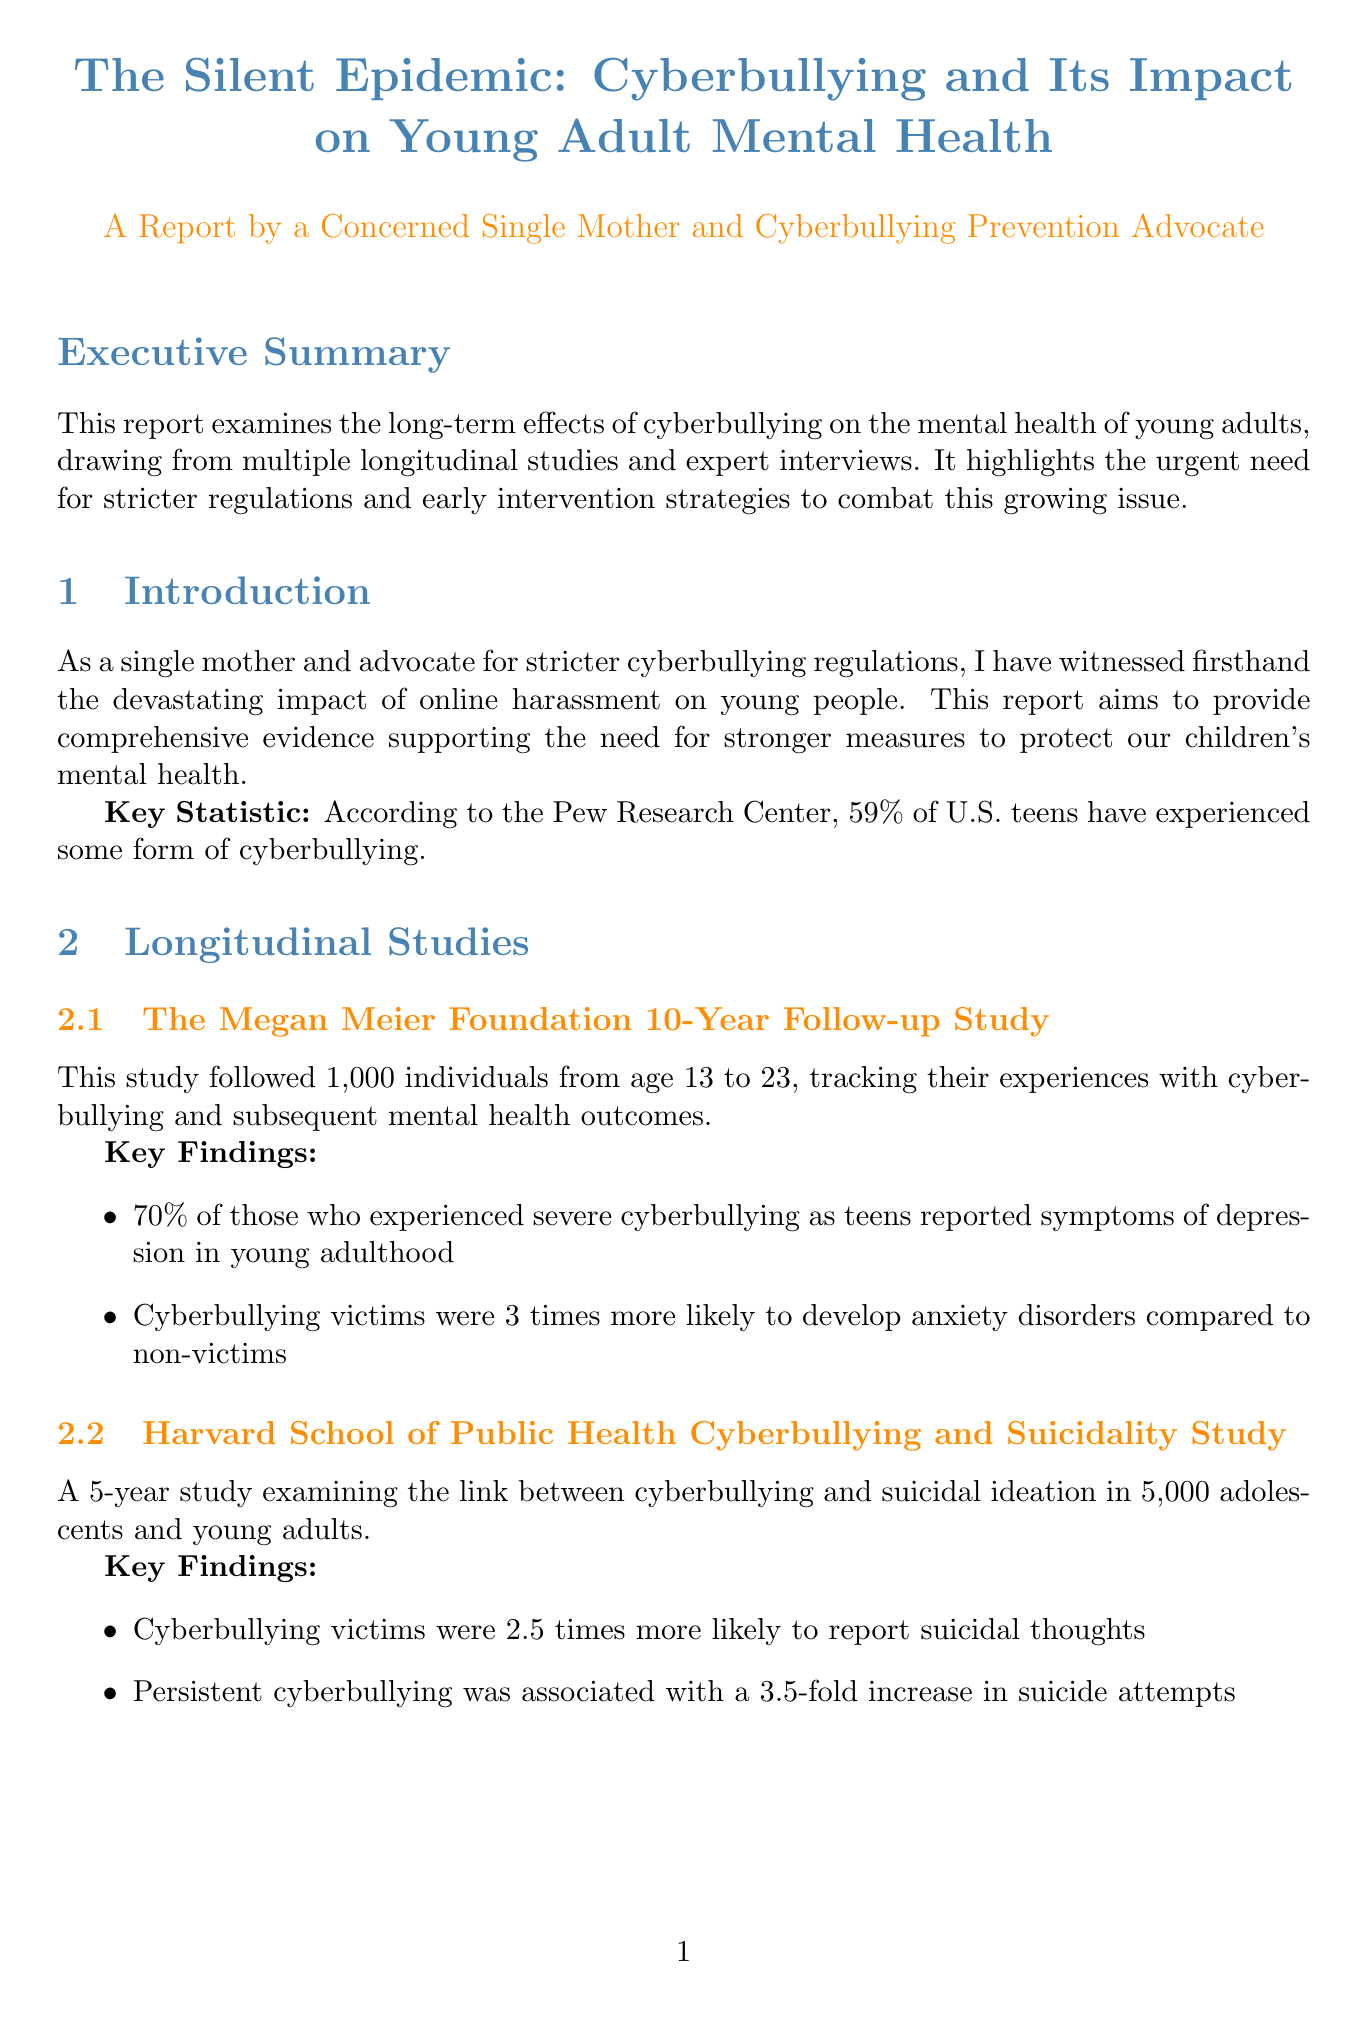what is the title of the report? The title is stated at the beginning of the document and emphasizes the correlation between cyberbullying and mental health.
Answer: The Silent Epidemic: Cyberbullying and Its Impact on Young Adult Mental Health how many teens experience cyberbullying according to the Pew Research Center? The report cites a key statistic from the Pew Research Center regarding the percentage of U.S. teens who have experienced cyberbullying.
Answer: 59% what percentage of severe cyberbullying victims reported symptoms of depression? This statistic is found under the key findings of the Megan Meier Foundation study, highlighting a severe mental health consequence.
Answer: 70% how much did cyberbullying incidents decrease in California after the Digital Empathy Education Program was implemented? This information is provided as an implementation example for the intervention strategy aimed at decreasing cyberbullying incidents.
Answer: 40% what law proposes to improve accountability for social media companies regarding cyberbullying? The document outlines recommended regulations, including a specific law targeting social media company responses to bullying incidents.
Answer: Social Media Platform Accountability Law who is the clinical psychologist quoted in the report? The expert opinions section contains quotes from professionals in the field, including their names and affiliations.
Answer: Dr. Samantha Cohen what is the proposed potential impact of the Mandatory Cyberbullying Education Act? This information is outlined in the regulatory recommendations section, discussing expectations of the proposed act.
Answer: Could reduce cyberbullying incidents by up to 50% what is one strategy mentioned for early intervention? The document lists several strategies for early intervention against cyberbullying, with descriptions and examples.
Answer: Digital Empathy Education Program 